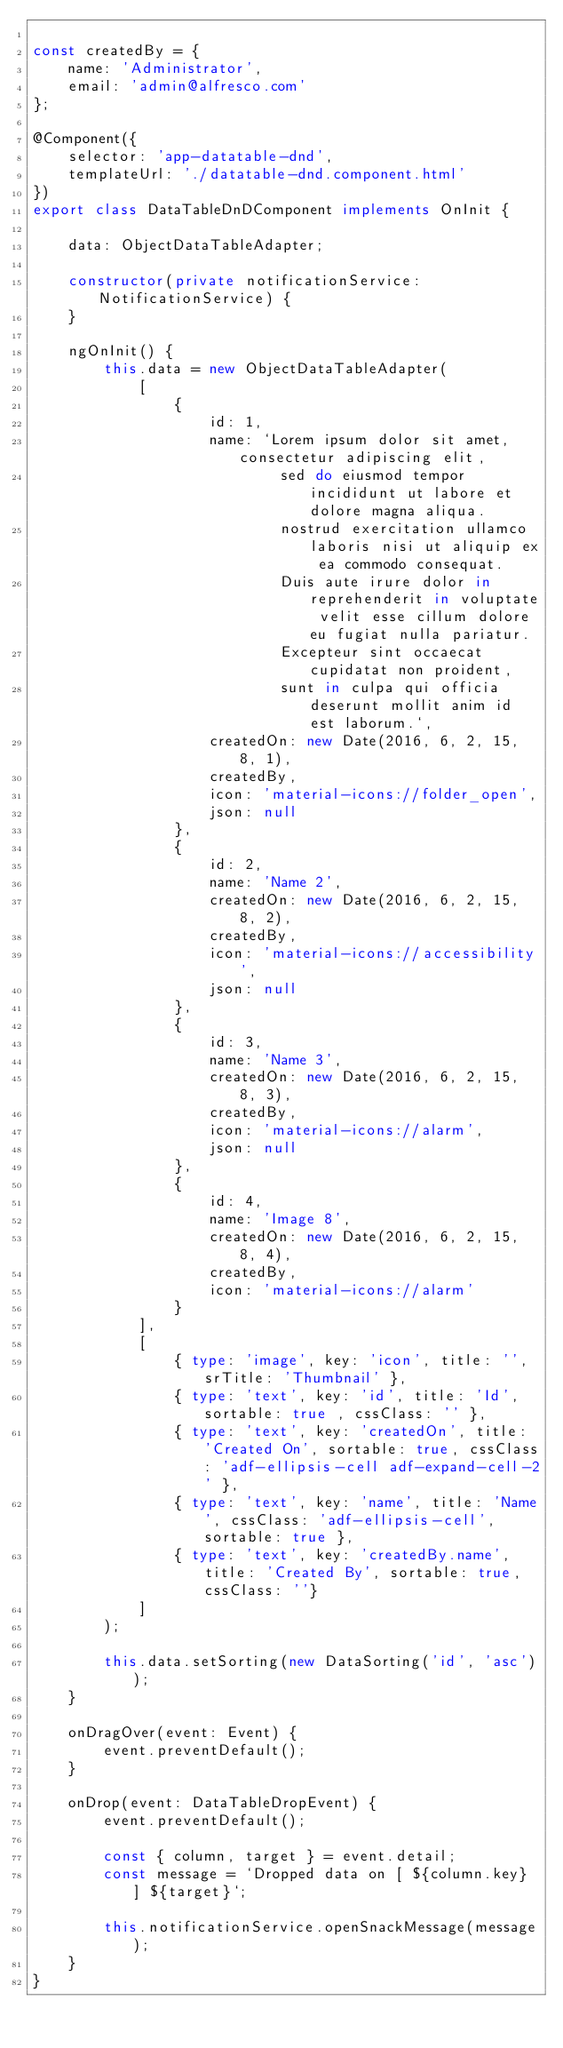<code> <loc_0><loc_0><loc_500><loc_500><_TypeScript_>
const createdBy = {
    name: 'Administrator',
    email: 'admin@alfresco.com'
};

@Component({
    selector: 'app-datatable-dnd',
    templateUrl: './datatable-dnd.component.html'
})
export class DataTableDnDComponent implements OnInit {

    data: ObjectDataTableAdapter;

    constructor(private notificationService: NotificationService) {
    }

    ngOnInit() {
        this.data = new ObjectDataTableAdapter(
            [
                {
                    id: 1,
                    name: `Lorem ipsum dolor sit amet, consectetur adipiscing elit,
                            sed do eiusmod tempor incididunt ut labore et dolore magna aliqua.
                            nostrud exercitation ullamco laboris nisi ut aliquip ex ea commodo consequat.
                            Duis aute irure dolor in reprehenderit in voluptate velit esse cillum dolore eu fugiat nulla pariatur.
                            Excepteur sint occaecat cupidatat non proident,
                            sunt in culpa qui officia deserunt mollit anim id est laborum.`,
                    createdOn: new Date(2016, 6, 2, 15, 8, 1),
                    createdBy,
                    icon: 'material-icons://folder_open',
                    json: null
                },
                {
                    id: 2,
                    name: 'Name 2',
                    createdOn: new Date(2016, 6, 2, 15, 8, 2),
                    createdBy,
                    icon: 'material-icons://accessibility',
                    json: null
                },
                {
                    id: 3,
                    name: 'Name 3',
                    createdOn: new Date(2016, 6, 2, 15, 8, 3),
                    createdBy,
                    icon: 'material-icons://alarm',
                    json: null
                },
                {
                    id: 4,
                    name: 'Image 8',
                    createdOn: new Date(2016, 6, 2, 15, 8, 4),
                    createdBy,
                    icon: 'material-icons://alarm'
                }
            ],
            [
                { type: 'image', key: 'icon', title: '', srTitle: 'Thumbnail' },
                { type: 'text', key: 'id', title: 'Id', sortable: true , cssClass: '' },
                { type: 'text', key: 'createdOn', title: 'Created On', sortable: true, cssClass: 'adf-ellipsis-cell adf-expand-cell-2' },
                { type: 'text', key: 'name', title: 'Name', cssClass: 'adf-ellipsis-cell', sortable: true },
                { type: 'text', key: 'createdBy.name', title: 'Created By', sortable: true, cssClass: ''}
            ]
        );

        this.data.setSorting(new DataSorting('id', 'asc'));
    }

    onDragOver(event: Event) {
        event.preventDefault();
    }

    onDrop(event: DataTableDropEvent) {
        event.preventDefault();

        const { column, target } = event.detail;
        const message = `Dropped data on [ ${column.key} ] ${target}`;

        this.notificationService.openSnackMessage(message);
    }
}
</code> 